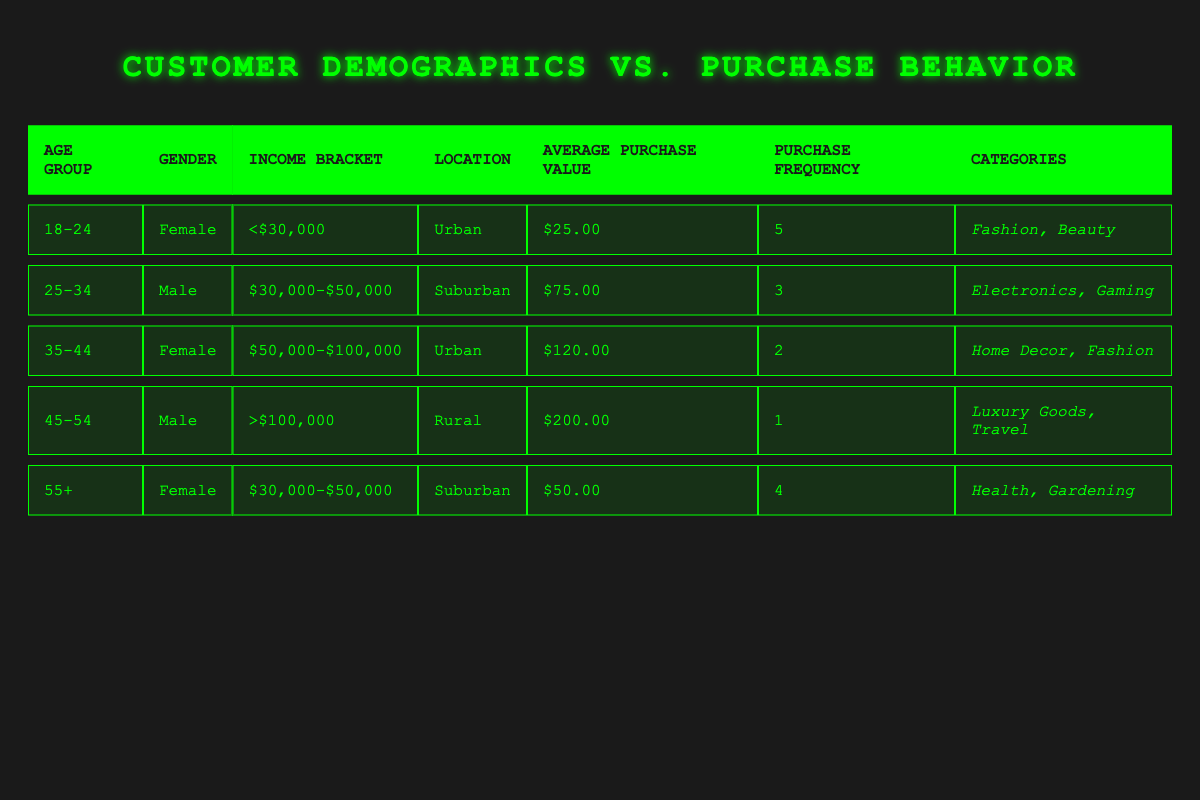What is the average purchase value for customers aged 18-24? The average purchase value for customers aged 18-24 is directly provided in the table under the column "Average Purchase Value." It lists "$25.00" corresponding to that age group.
Answer: $25.00 Which age group has the highest average purchase value? To find the age group with the highest average purchase value, we compare the values from each age group: 18-24 is $25.00, 25-34 is $75.00, 35-44 is $120.00, 45-54 is $200.00, and 55+ is $50.00. The highest value is $200.00 for the age group 45-54.
Answer: 45-54 Is there any female customer in the age group 35-44? Referring to the table, the 35-44 age group lists "Female" under the Gender column. This confirms that there is indeed a female customer in that age group.
Answer: Yes How many purchase categories are associated with customers in the 25-34 age group? The 25-34 age group is associated with the categories "Electronics" and "Gaming." By counting these categories, we find there are a total of 2 purchase categories listed.
Answer: 2 For customers aged 55 and above, what is the total average purchase value across all customers in that age group? According to the table, there is only one age group for customers aged 55+, with an average purchase value listed as $50.00. Therefore, the total average purchase value for that group is $50.00 since there are no other values to sum.
Answer: $50.00 What is the purchase frequency for male customers in the income bracket of $30,000-$50,000? The table shows that the male customer in the income bracket of $30,000-$50,000 (age group 25-34) has a purchase frequency of 3.
Answer: 3 How many total unique categories do the customers in the age group 18-24 purchase from? The 18-24 age group purchases from two categories: "Fashion" and "Beauty." They are distinct categories, so counting them gives a total of 2 unique categories.
Answer: 2 Which income bracket represents the highest average purchase value? The income brackets with associated average purchase values are: < $30,000 = $25.00, $30,000-$50,000 = $75.00, $50,000-$100,000 = $120.00, > $100,000 = $200.00. The highest average purchase value of $200.00 is for the income bracket > $100,000, thus that is the greatest.
Answer: >$100,000 What is the difference in average purchase value between the age groups 25-34 and 35-44? The average purchase value for the age group 25-34 is $75.00, while for 35-44 it is $120.00. To find the difference, we calculate $120.00 - $75.00 = $45.00.
Answer: $45.00 